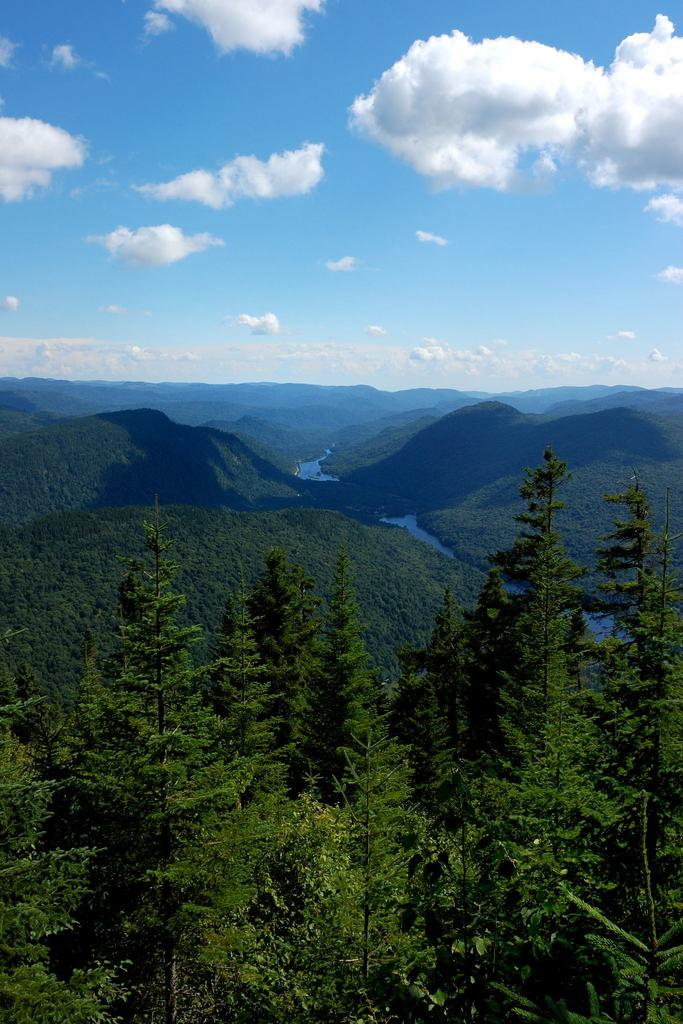What type of natural features can be seen in the image? There are trees and mountains in the image. What is the water flow like in the image? The water flow is visible in the image. What is visible in the background of the image? The sky is visible in the background of the image, and clouds are present. What type of screw can be seen holding the collar in place in the image? There is no screw or collar present in the image; it features natural elements such as trees, mountains, and water flow. 